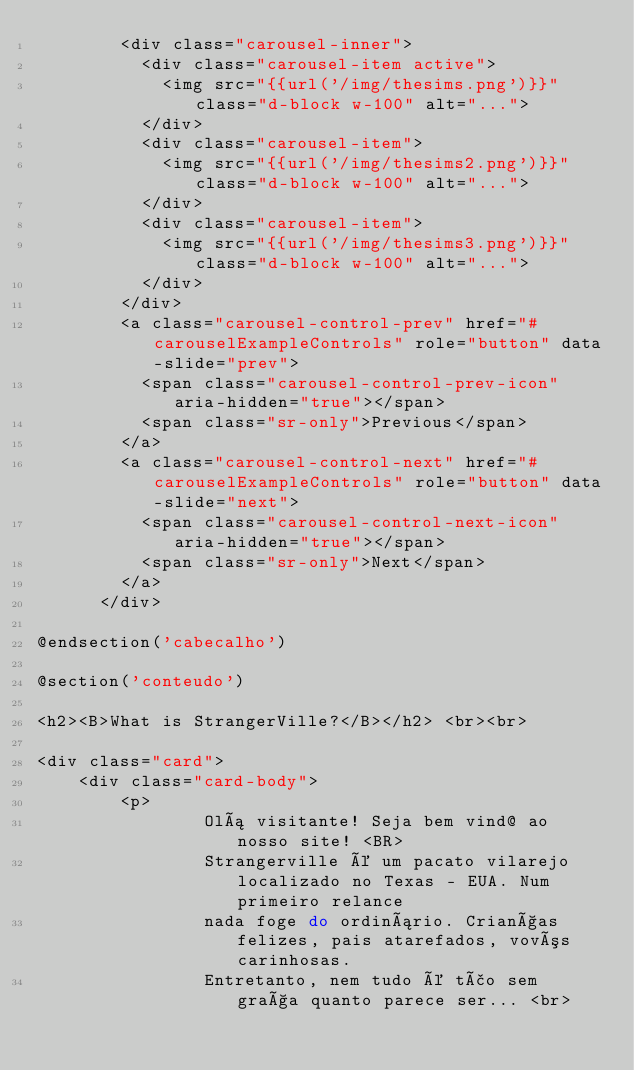<code> <loc_0><loc_0><loc_500><loc_500><_PHP_>        <div class="carousel-inner">
          <div class="carousel-item active">
            <img src="{{url('/img/thesims.png')}}" class="d-block w-100" alt="...">
          </div>
          <div class="carousel-item">
            <img src="{{url('/img/thesims2.png')}}" class="d-block w-100" alt="...">
          </div>
          <div class="carousel-item">
            <img src="{{url('/img/thesims3.png')}}" class="d-block w-100" alt="...">
          </div>
        </div>
        <a class="carousel-control-prev" href="#carouselExampleControls" role="button" data-slide="prev">
          <span class="carousel-control-prev-icon" aria-hidden="true"></span>
          <span class="sr-only">Previous</span>
        </a>
        <a class="carousel-control-next" href="#carouselExampleControls" role="button" data-slide="next">
          <span class="carousel-control-next-icon" aria-hidden="true"></span>
          <span class="sr-only">Next</span>
        </a>
      </div>

@endsection('cabecalho')

@section('conteudo')

<h2><B>What is StrangerVille?</B></h2> <br><br>

<div class="card">
    <div class="card-body">
        <p>
                Olá visitante! Seja bem vind@ ao nosso site! <BR>
                Strangerville é um pacato vilarejo localizado no Texas - EUA. Num primeiro relance
                nada foge do ordinário. Crianças felizes, pais atarefados, vovós carinhosas.
                Entretanto, nem tudo é tão sem graça quanto parece ser... <br></code> 